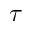Convert formula to latex. <formula><loc_0><loc_0><loc_500><loc_500>\tau</formula> 